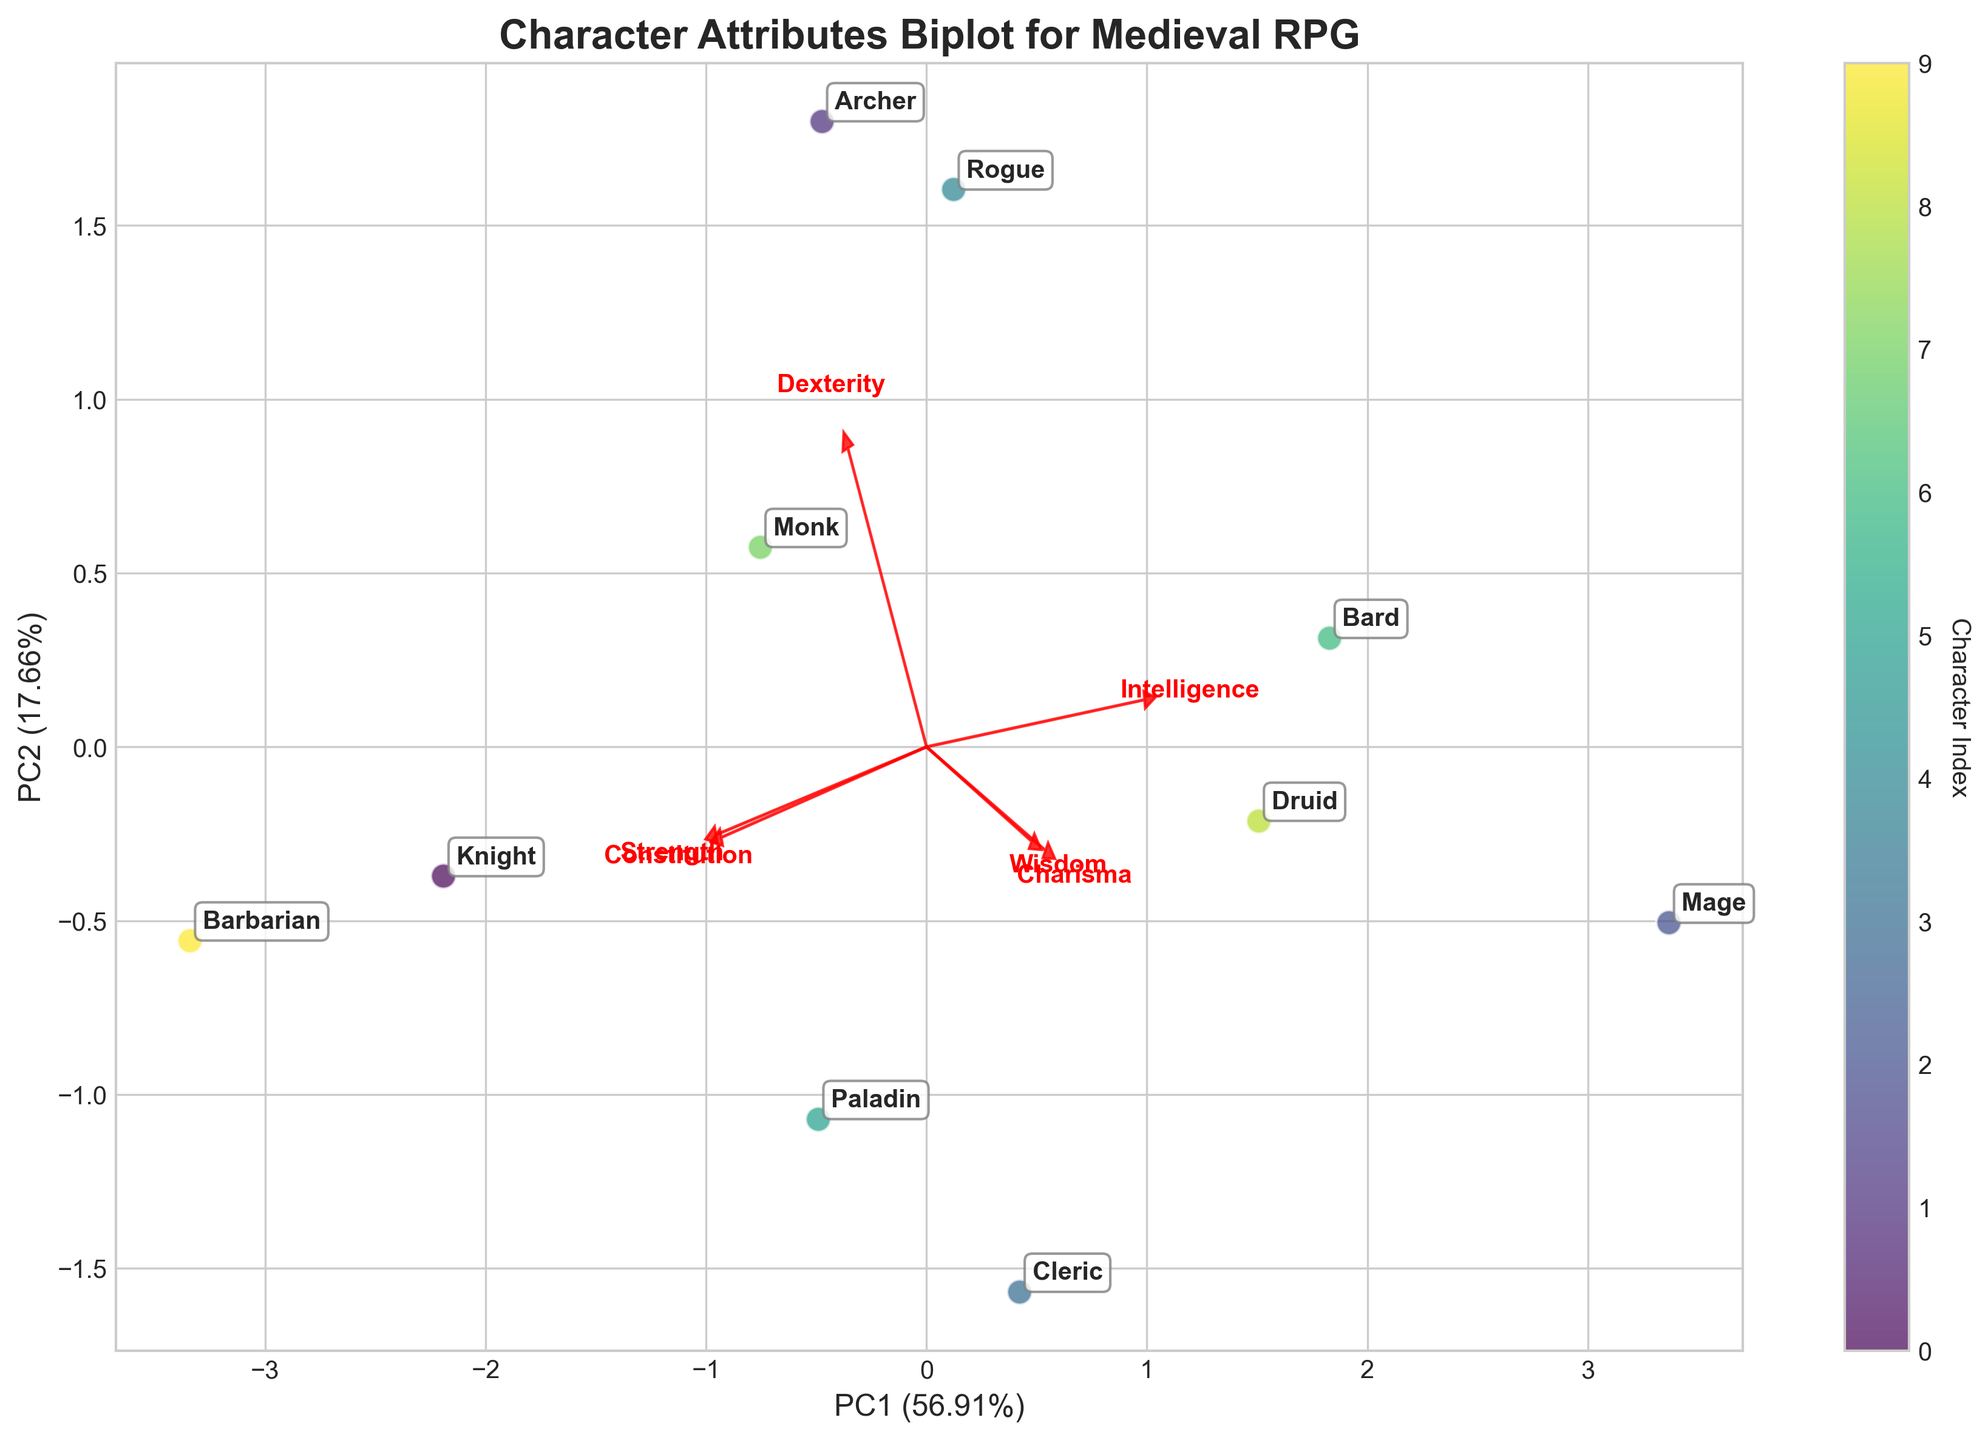Which character has the highest value for Strength on the biplot, and how can you identify this? By interpreting the figure, you can identify each character's attributes based on their positioning in relation to the eigenvector arrows. The character farthest in the direction of the "Strength" arrow will have the highest strength value. In this case, that character is the Barbarian.
Answer: Barbarian How are the physical attributes (Strength, Dexterity, Constitution) generally positioned in the biplot compared to the mental attributes (Intelligence, Wisdom, Charisma)? The physical attributes will be grouped and reflected in a similar direction based on their vectors, while the mental attributes will likely be positioned in another distinct direction. For instance, physical attributes will be closer together and might be orthogonal or opposite to mental attributes, indicating their difference.
Answer: Physical attributes and mental attributes have distinct orientations Which two characters are the most similar in terms of their attributes, according to the biplot? By examining the proximity of the characters' data points on the plot, the two characters closest to each other will have the most similar attributes. In this figure, the Monk and the Knight are placed very closely, indicating their attributes are quite similar.
Answer: Monk and Knight Which character has a higher combination of Dexterity and Wisdom, the Rogue or the Cleric? To determine this, observe the positions relative to the Dexterity and Wisdom arrows. The character closer to the arrow tips for both attributes will have a higher combination. In this plot, Cleric is closer to both the Dexterity and Wisdom arrows, making it higher in those attributes combined compared to the Rogue.
Answer: Cleric Character with highest influence from PC1 By interpreting the figure, PC1 (first Principal Component) is the horizontal axis. The character farthest along this axis has the highest influence. In this case, the Barbarian is the farthest along PC1.
Answer: Barbarian 